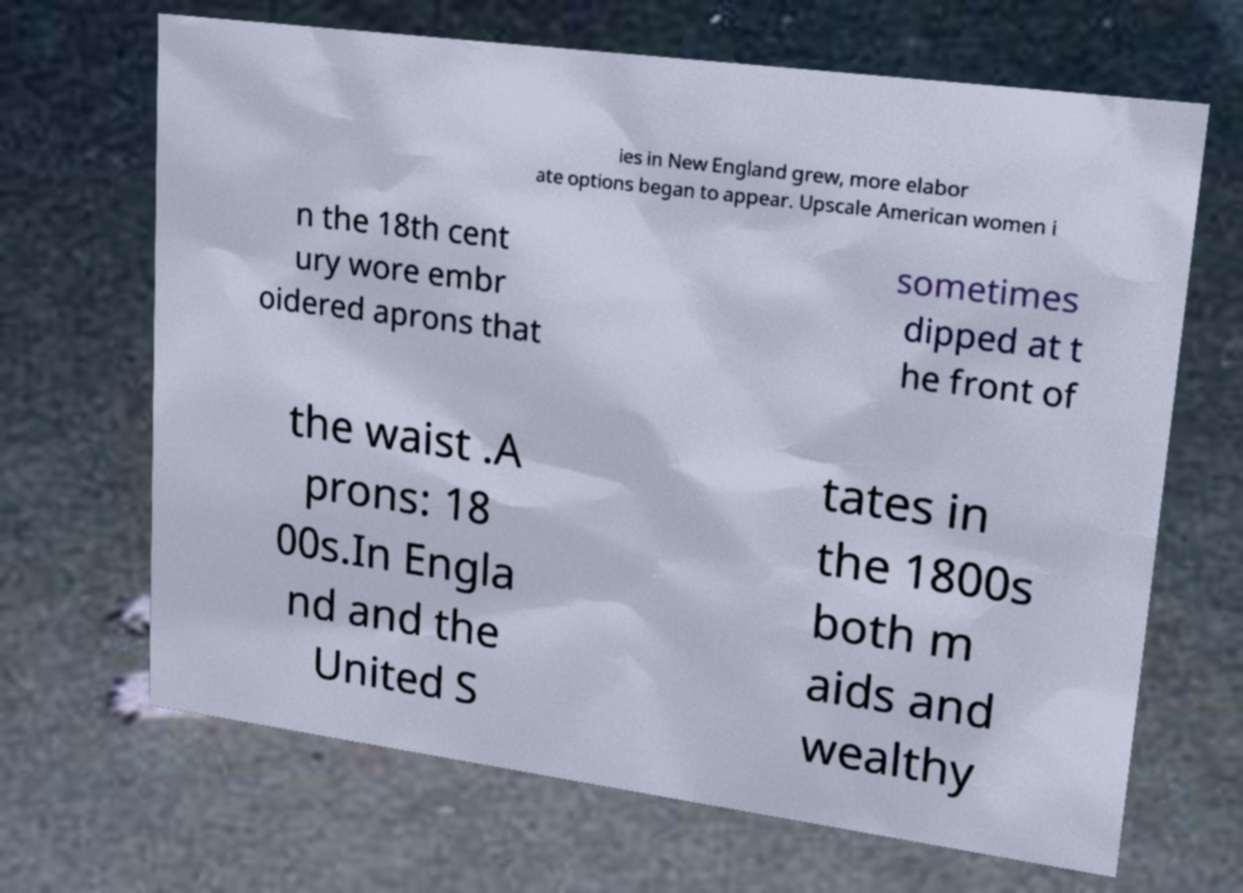Can you accurately transcribe the text from the provided image for me? ies in New England grew, more elabor ate options began to appear. Upscale American women i n the 18th cent ury wore embr oidered aprons that sometimes dipped at t he front of the waist .A prons: 18 00s.In Engla nd and the United S tates in the 1800s both m aids and wealthy 